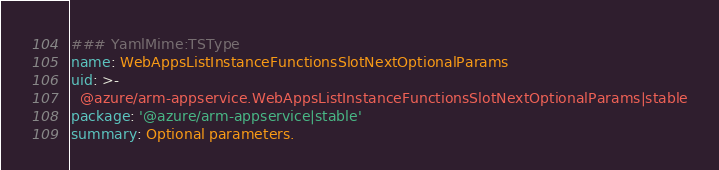Convert code to text. <code><loc_0><loc_0><loc_500><loc_500><_YAML_>### YamlMime:TSType
name: WebAppsListInstanceFunctionsSlotNextOptionalParams
uid: >-
  @azure/arm-appservice.WebAppsListInstanceFunctionsSlotNextOptionalParams|stable
package: '@azure/arm-appservice|stable'
summary: Optional parameters.</code> 